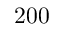<formula> <loc_0><loc_0><loc_500><loc_500>2 0 0</formula> 